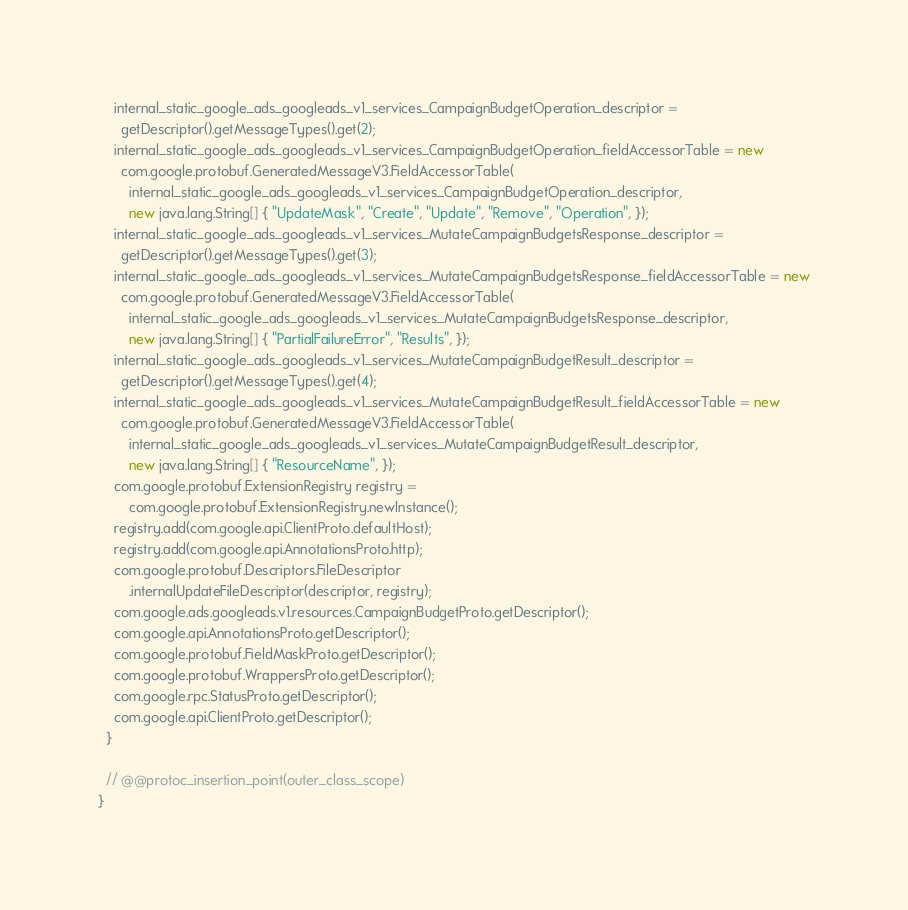Convert code to text. <code><loc_0><loc_0><loc_500><loc_500><_Java_>    internal_static_google_ads_googleads_v1_services_CampaignBudgetOperation_descriptor =
      getDescriptor().getMessageTypes().get(2);
    internal_static_google_ads_googleads_v1_services_CampaignBudgetOperation_fieldAccessorTable = new
      com.google.protobuf.GeneratedMessageV3.FieldAccessorTable(
        internal_static_google_ads_googleads_v1_services_CampaignBudgetOperation_descriptor,
        new java.lang.String[] { "UpdateMask", "Create", "Update", "Remove", "Operation", });
    internal_static_google_ads_googleads_v1_services_MutateCampaignBudgetsResponse_descriptor =
      getDescriptor().getMessageTypes().get(3);
    internal_static_google_ads_googleads_v1_services_MutateCampaignBudgetsResponse_fieldAccessorTable = new
      com.google.protobuf.GeneratedMessageV3.FieldAccessorTable(
        internal_static_google_ads_googleads_v1_services_MutateCampaignBudgetsResponse_descriptor,
        new java.lang.String[] { "PartialFailureError", "Results", });
    internal_static_google_ads_googleads_v1_services_MutateCampaignBudgetResult_descriptor =
      getDescriptor().getMessageTypes().get(4);
    internal_static_google_ads_googleads_v1_services_MutateCampaignBudgetResult_fieldAccessorTable = new
      com.google.protobuf.GeneratedMessageV3.FieldAccessorTable(
        internal_static_google_ads_googleads_v1_services_MutateCampaignBudgetResult_descriptor,
        new java.lang.String[] { "ResourceName", });
    com.google.protobuf.ExtensionRegistry registry =
        com.google.protobuf.ExtensionRegistry.newInstance();
    registry.add(com.google.api.ClientProto.defaultHost);
    registry.add(com.google.api.AnnotationsProto.http);
    com.google.protobuf.Descriptors.FileDescriptor
        .internalUpdateFileDescriptor(descriptor, registry);
    com.google.ads.googleads.v1.resources.CampaignBudgetProto.getDescriptor();
    com.google.api.AnnotationsProto.getDescriptor();
    com.google.protobuf.FieldMaskProto.getDescriptor();
    com.google.protobuf.WrappersProto.getDescriptor();
    com.google.rpc.StatusProto.getDescriptor();
    com.google.api.ClientProto.getDescriptor();
  }

  // @@protoc_insertion_point(outer_class_scope)
}
</code> 